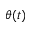<formula> <loc_0><loc_0><loc_500><loc_500>\theta ( t )</formula> 